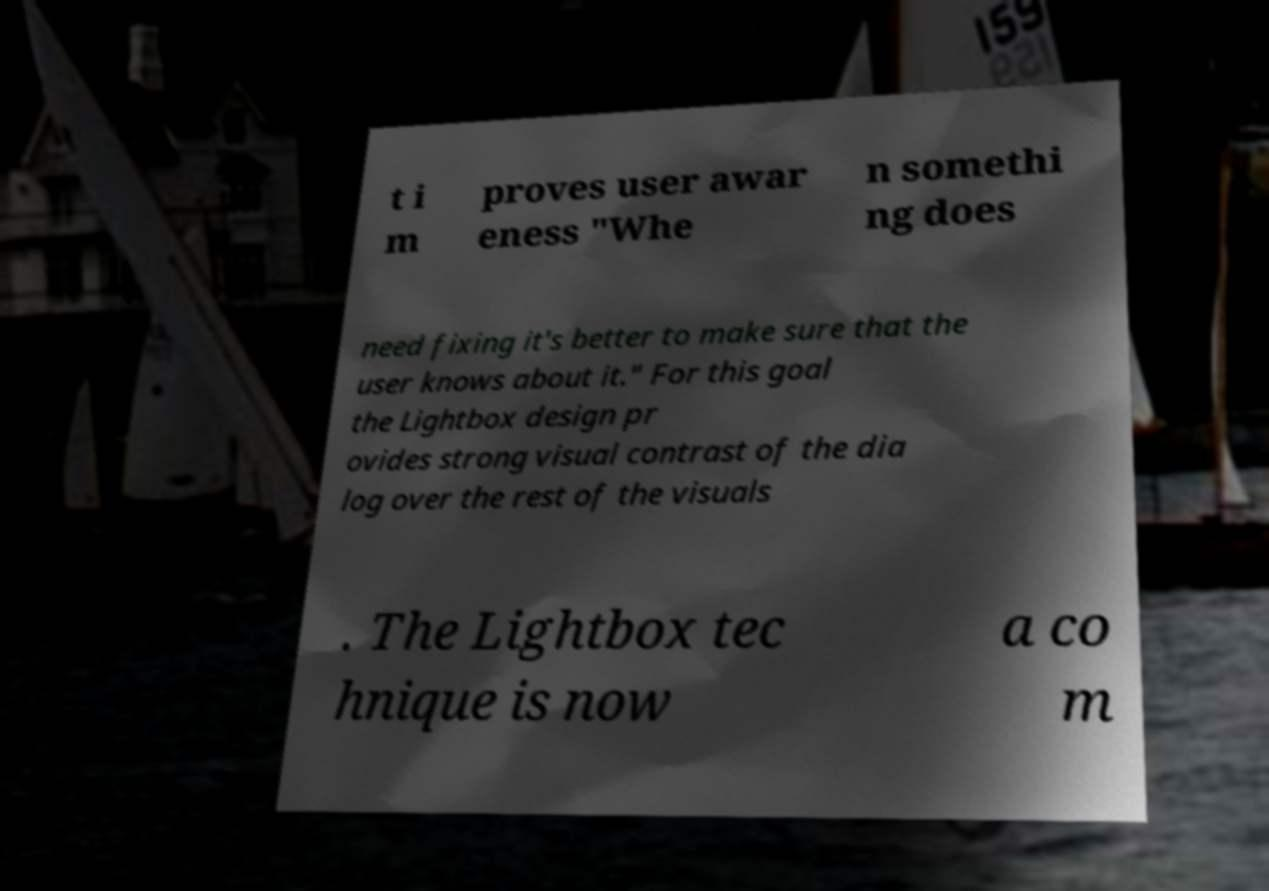Could you extract and type out the text from this image? t i m proves user awar eness "Whe n somethi ng does need fixing it's better to make sure that the user knows about it." For this goal the Lightbox design pr ovides strong visual contrast of the dia log over the rest of the visuals . The Lightbox tec hnique is now a co m 